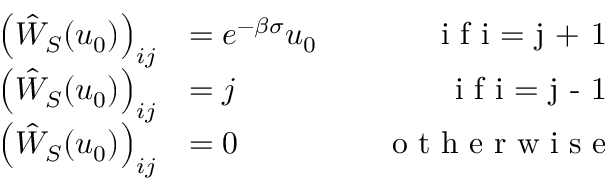<formula> <loc_0><loc_0><loc_500><loc_500>\begin{array} { r l r } { \left ( \hat { W } _ { S } ( u _ { 0 } ) \right ) _ { i j } } & { = e ^ { - \beta \sigma } u _ { 0 } \quad } & { i f i = j + 1 } \\ { \left ( \hat { W } _ { S } ( u _ { 0 } ) \right ) _ { i j } } & { = j \quad } & { i f i = j - 1 } \\ { \left ( \hat { W } _ { S } ( u _ { 0 } ) \right ) _ { i j } } & { = 0 \quad } & { o t h e r w i s e } \end{array}</formula> 